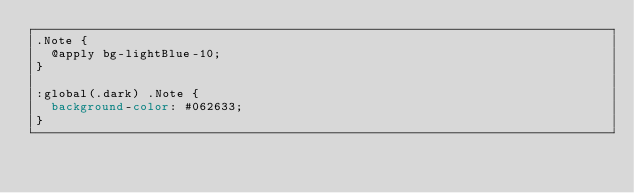<code> <loc_0><loc_0><loc_500><loc_500><_CSS_>.Note {
  @apply bg-lightBlue-10;
}

:global(.dark) .Note {
  background-color: #062633;
}
</code> 